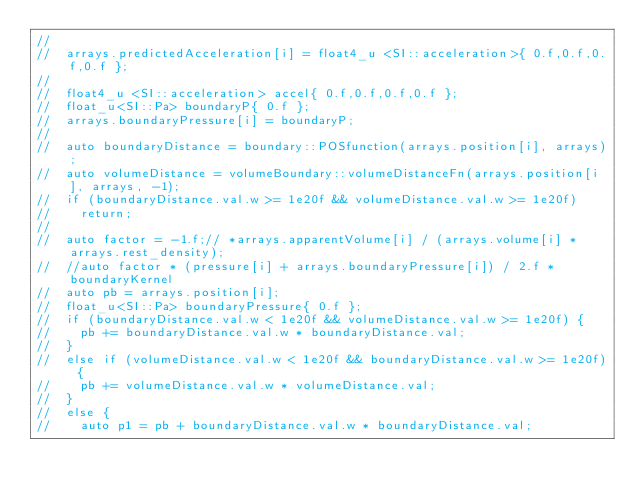<code> <loc_0><loc_0><loc_500><loc_500><_Cuda_>//
//	arrays.predictedAcceleration[i] = float4_u <SI::acceleration>{ 0.f,0.f,0.f,0.f };
//
//	float4_u <SI::acceleration> accel{ 0.f,0.f,0.f,0.f };
//	float_u<SI::Pa> boundaryP{ 0.f };
//	arrays.boundaryPressure[i] = boundaryP;
//
//	auto boundaryDistance = boundary::POSfunction(arrays.position[i], arrays);
//	auto volumeDistance = volumeBoundary::volumeDistanceFn(arrays.position[i], arrays, -1);
//	if (boundaryDistance.val.w >= 1e20f && volumeDistance.val.w >= 1e20f)
//		return;
//
//	auto factor = -1.f;// *arrays.apparentVolume[i] / (arrays.volume[i] * arrays.rest_density);
//	//auto factor * (pressure[i] + arrays.boundaryPressure[i]) / 2.f * boundaryKernel
//	auto pb = arrays.position[i];
//	float_u<SI::Pa> boundaryPressure{ 0.f };
//	if (boundaryDistance.val.w < 1e20f && volumeDistance.val.w >= 1e20f) {
//		pb += boundaryDistance.val.w * boundaryDistance.val;
//	}
//	else if (volumeDistance.val.w < 1e20f && boundaryDistance.val.w >= 1e20f) {
//		pb += volumeDistance.val.w * volumeDistance.val;
//	}
//	else {
//		auto p1 = pb + boundaryDistance.val.w * boundaryDistance.val;</code> 